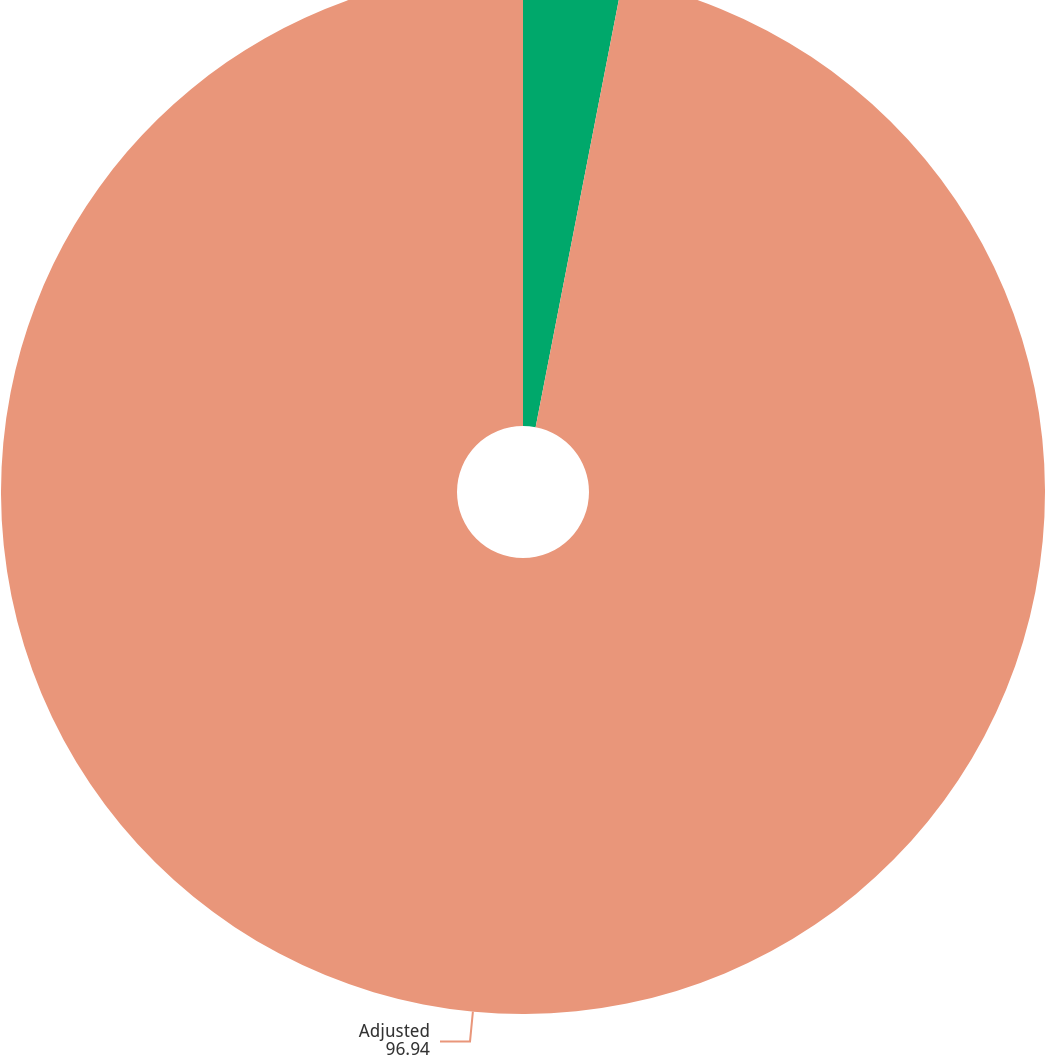Convert chart. <chart><loc_0><loc_0><loc_500><loc_500><pie_chart><fcel>As reported<fcel>Adjusted<nl><fcel>3.06%<fcel>96.94%<nl></chart> 